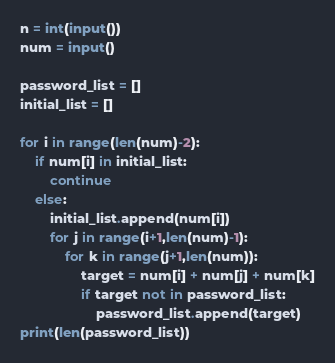<code> <loc_0><loc_0><loc_500><loc_500><_Python_>n = int(input())
num = input()
 
password_list = []
initial_list = []
 
for i in range(len(num)-2):
    if num[i] in initial_list:
        continue
    else:
        initial_list.append(num[i])
        for j in range(i+1,len(num)-1):
            for k in range(j+1,len(num)):
                target = num[i] + num[j] + num[k]
                if target not in password_list:
                    password_list.append(target)
print(len(password_list))</code> 